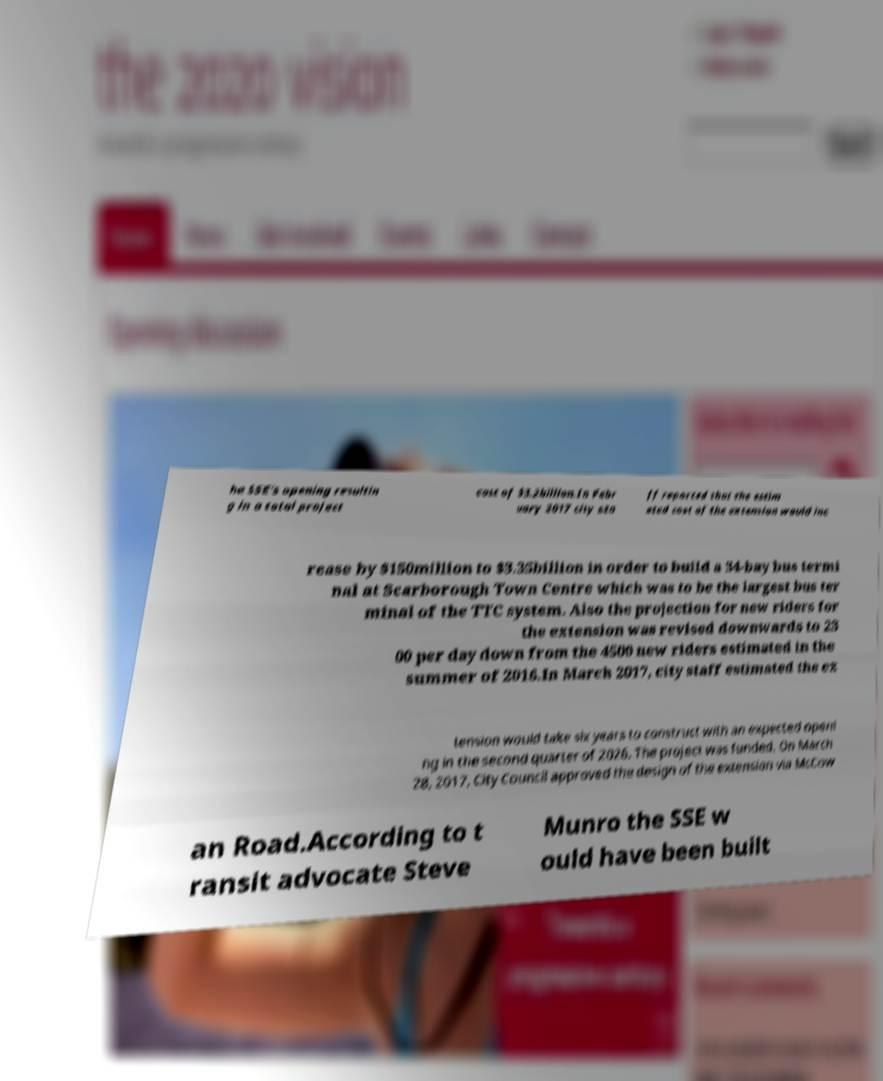Could you assist in decoding the text presented in this image and type it out clearly? he SSE's opening resultin g in a total project cost of $3.2billion.In Febr uary 2017 city sta ff reported that the estim ated cost of the extension would inc rease by $150million to $3.35billion in order to build a 34-bay bus termi nal at Scarborough Town Centre which was to be the largest bus ter minal of the TTC system. Also the projection for new riders for the extension was revised downwards to 23 00 per day down from the 4500 new riders estimated in the summer of 2016.In March 2017, city staff estimated the ex tension would take six years to construct with an expected openi ng in the second quarter of 2026. The project was funded. On March 28, 2017, City Council approved the design of the extension via McCow an Road.According to t ransit advocate Steve Munro the SSE w ould have been built 